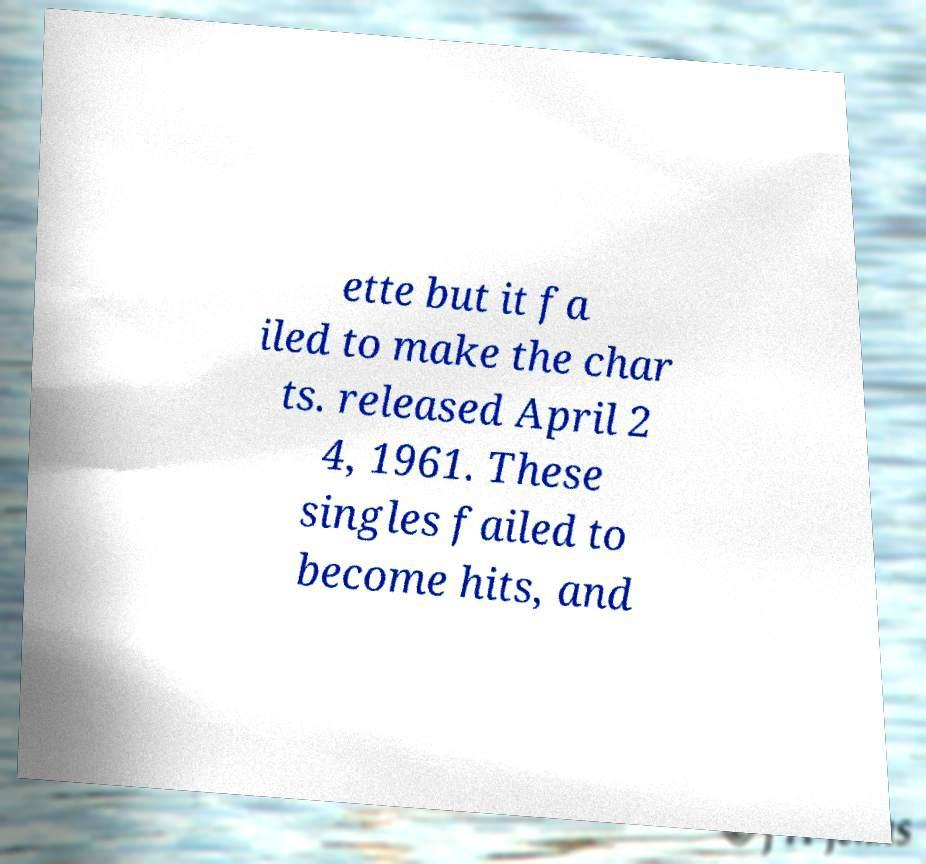What messages or text are displayed in this image? I need them in a readable, typed format. ette but it fa iled to make the char ts. released April 2 4, 1961. These singles failed to become hits, and 